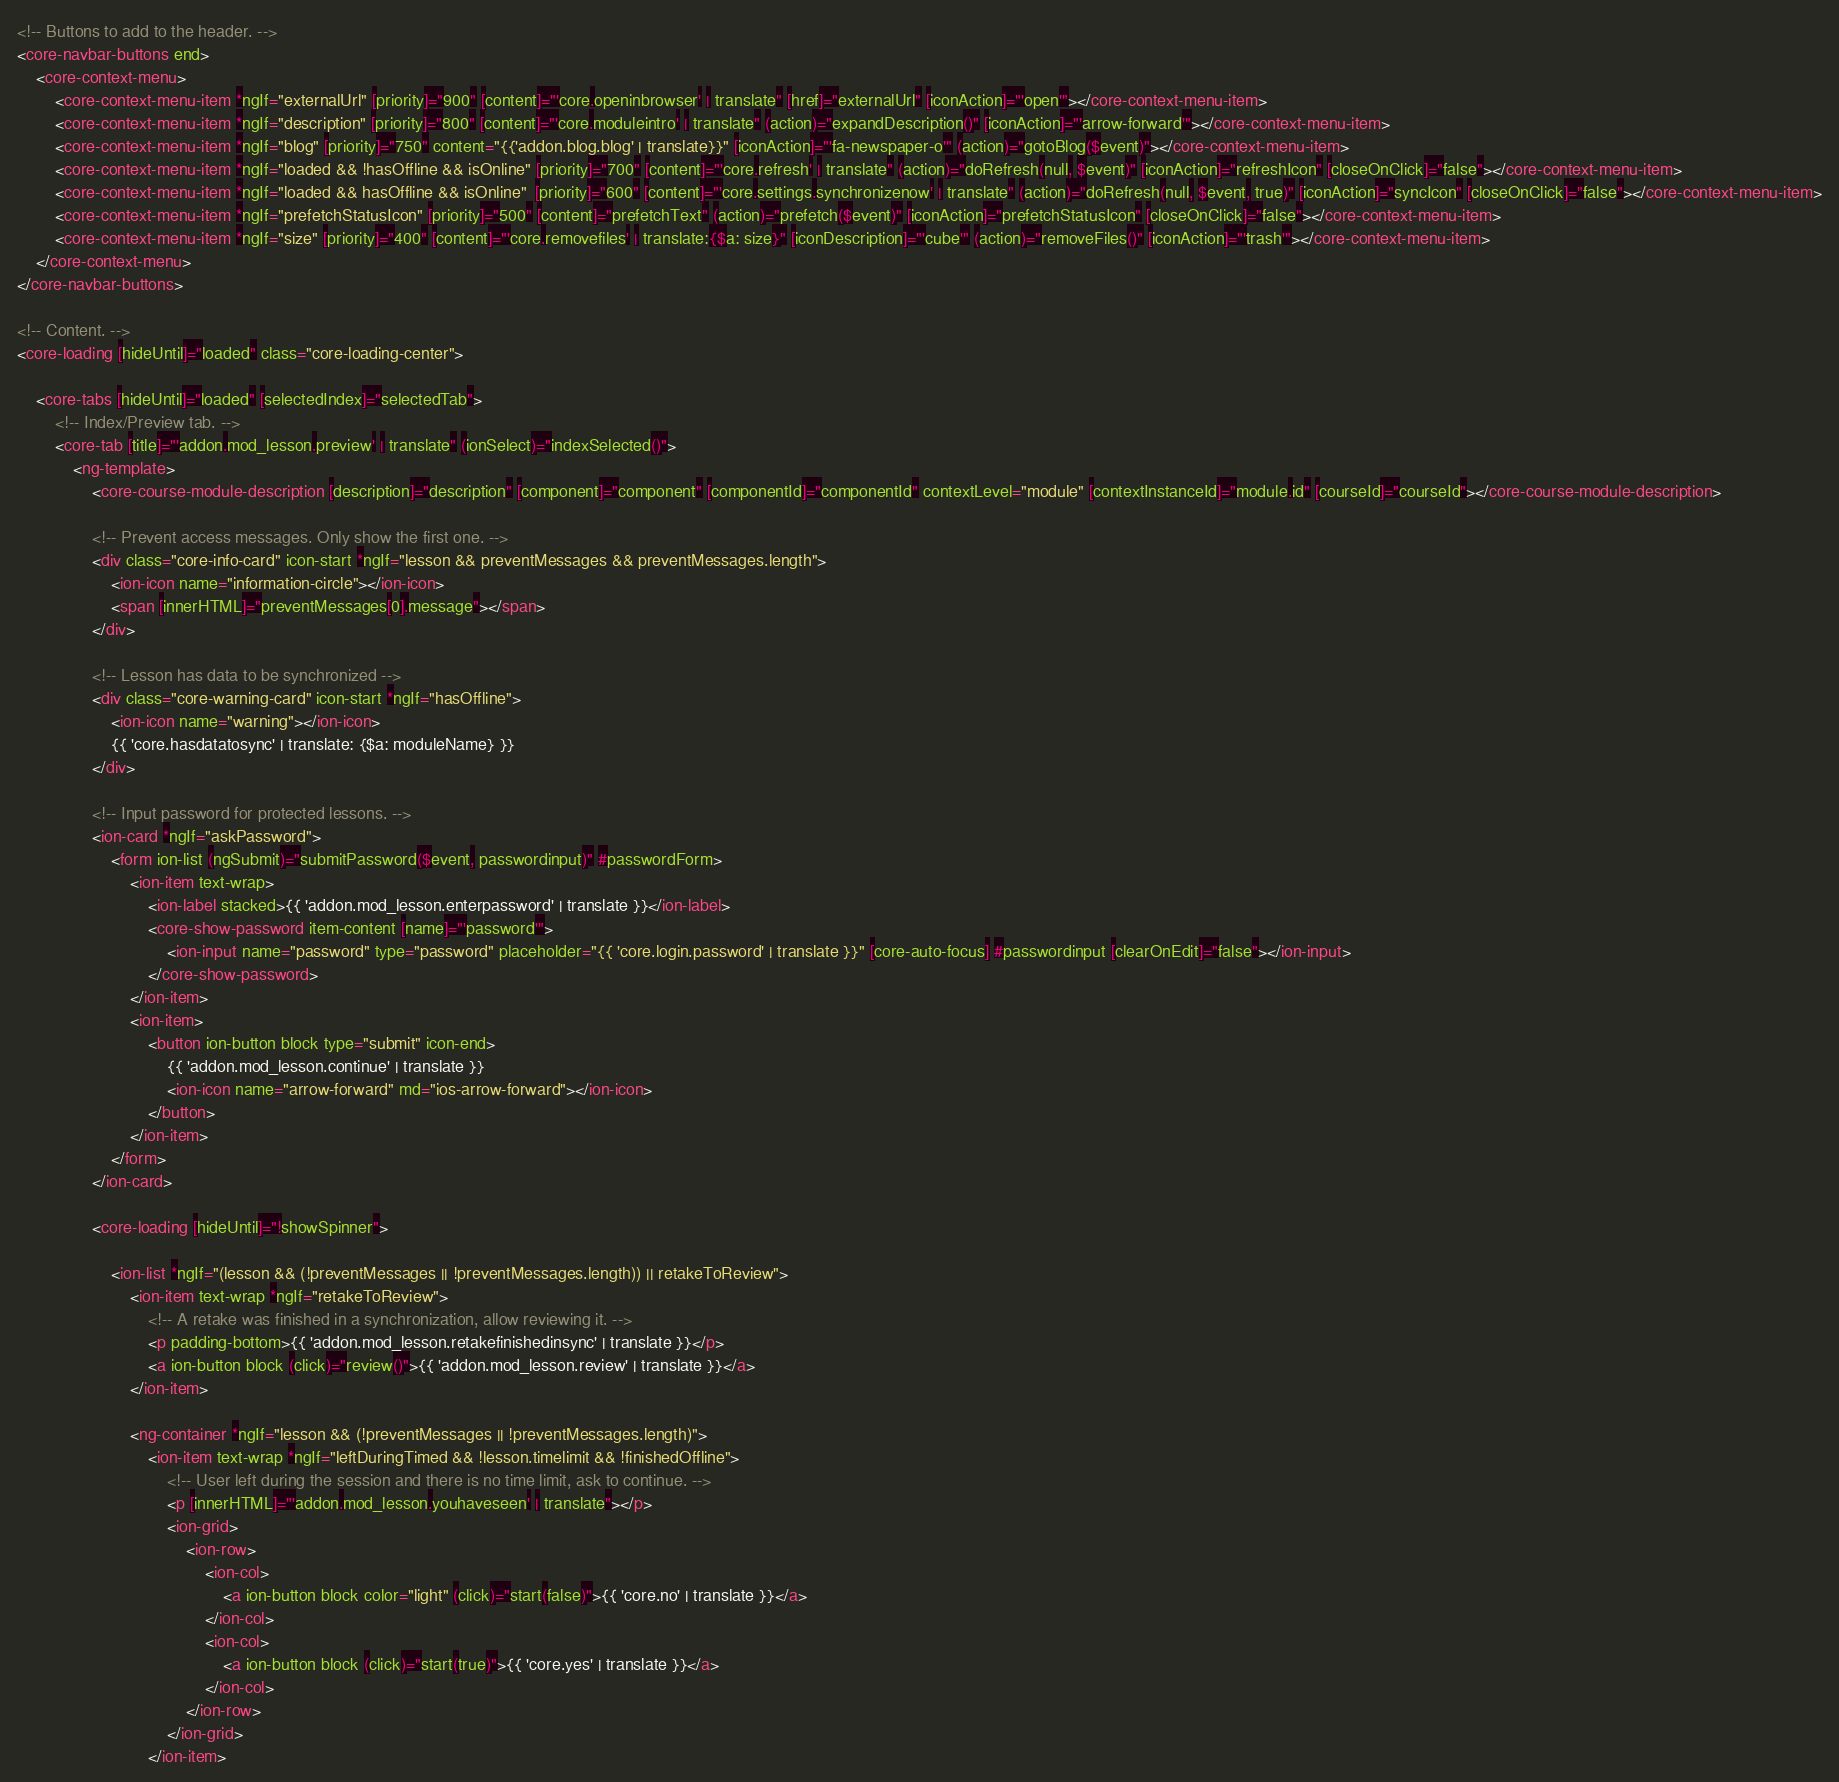<code> <loc_0><loc_0><loc_500><loc_500><_HTML_><!-- Buttons to add to the header. -->
<core-navbar-buttons end>
    <core-context-menu>
        <core-context-menu-item *ngIf="externalUrl" [priority]="900" [content]="'core.openinbrowser' | translate" [href]="externalUrl" [iconAction]="'open'"></core-context-menu-item>
        <core-context-menu-item *ngIf="description" [priority]="800" [content]="'core.moduleintro' | translate" (action)="expandDescription()" [iconAction]="'arrow-forward'"></core-context-menu-item>
        <core-context-menu-item *ngIf="blog" [priority]="750" content="{{'addon.blog.blog' | translate}}" [iconAction]="'fa-newspaper-o'" (action)="gotoBlog($event)"></core-context-menu-item>
        <core-context-menu-item *ngIf="loaded && !hasOffline && isOnline" [priority]="700" [content]="'core.refresh' | translate" (action)="doRefresh(null, $event)" [iconAction]="refreshIcon" [closeOnClick]="false"></core-context-menu-item>
        <core-context-menu-item *ngIf="loaded && hasOffline && isOnline"  [priority]="600" [content]="'core.settings.synchronizenow' | translate" (action)="doRefresh(null, $event, true)" [iconAction]="syncIcon" [closeOnClick]="false"></core-context-menu-item>
        <core-context-menu-item *ngIf="prefetchStatusIcon" [priority]="500" [content]="prefetchText" (action)="prefetch($event)" [iconAction]="prefetchStatusIcon" [closeOnClick]="false"></core-context-menu-item>
        <core-context-menu-item *ngIf="size" [priority]="400" [content]="'core.removefiles' | translate:{$a: size}" [iconDescription]="'cube'" (action)="removeFiles()" [iconAction]="'trash'"></core-context-menu-item>
    </core-context-menu>
</core-navbar-buttons>

<!-- Content. -->
<core-loading [hideUntil]="loaded" class="core-loading-center">

    <core-tabs [hideUntil]="loaded" [selectedIndex]="selectedTab">
        <!-- Index/Preview tab. -->
        <core-tab [title]="'addon.mod_lesson.preview' | translate" (ionSelect)="indexSelected()">
            <ng-template>
                <core-course-module-description [description]="description" [component]="component" [componentId]="componentId" contextLevel="module" [contextInstanceId]="module.id" [courseId]="courseId"></core-course-module-description>

                <!-- Prevent access messages. Only show the first one. -->
                <div class="core-info-card" icon-start *ngIf="lesson && preventMessages && preventMessages.length">
                    <ion-icon name="information-circle"></ion-icon>
                    <span [innerHTML]="preventMessages[0].message"></span>
                </div>

                <!-- Lesson has data to be synchronized -->
                <div class="core-warning-card" icon-start *ngIf="hasOffline">
                    <ion-icon name="warning"></ion-icon>
                    {{ 'core.hasdatatosync' | translate: {$a: moduleName} }}
                </div>

                <!-- Input password for protected lessons. -->
                <ion-card *ngIf="askPassword">
                    <form ion-list (ngSubmit)="submitPassword($event, passwordinput)" #passwordForm>
                        <ion-item text-wrap>
                            <ion-label stacked>{{ 'addon.mod_lesson.enterpassword' | translate }}</ion-label>
                            <core-show-password item-content [name]="'password'">
                                <ion-input name="password" type="password" placeholder="{{ 'core.login.password' | translate }}" [core-auto-focus] #passwordinput [clearOnEdit]="false"></ion-input>
                            </core-show-password>
                        </ion-item>
                        <ion-item>
                            <button ion-button block type="submit" icon-end>
                                {{ 'addon.mod_lesson.continue' | translate }}
                                <ion-icon name="arrow-forward" md="ios-arrow-forward"></ion-icon>
                            </button>
                        </ion-item>
                    </form>
                </ion-card>

                <core-loading [hideUntil]="!showSpinner">

                    <ion-list *ngIf="(lesson && (!preventMessages || !preventMessages.length)) || retakeToReview">
                        <ion-item text-wrap *ngIf="retakeToReview">
                            <!-- A retake was finished in a synchronization, allow reviewing it. -->
                            <p padding-bottom>{{ 'addon.mod_lesson.retakefinishedinsync' | translate }}</p>
                            <a ion-button block (click)="review()">{{ 'addon.mod_lesson.review' | translate }}</a>
                        </ion-item>

                        <ng-container *ngIf="lesson && (!preventMessages || !preventMessages.length)">
                            <ion-item text-wrap *ngIf="leftDuringTimed && !lesson.timelimit && !finishedOffline">
                                <!-- User left during the session and there is no time limit, ask to continue. -->
                                <p [innerHTML]="'addon.mod_lesson.youhaveseen' | translate"></p>
                                <ion-grid>
                                    <ion-row>
                                        <ion-col>
                                            <a ion-button block color="light" (click)="start(false)">{{ 'core.no' | translate }}</a>
                                        </ion-col>
                                        <ion-col>
                                            <a ion-button block (click)="start(true)">{{ 'core.yes' | translate }}</a>
                                        </ion-col>
                                    </ion-row>
                                </ion-grid>
                            </ion-item>
</code> 